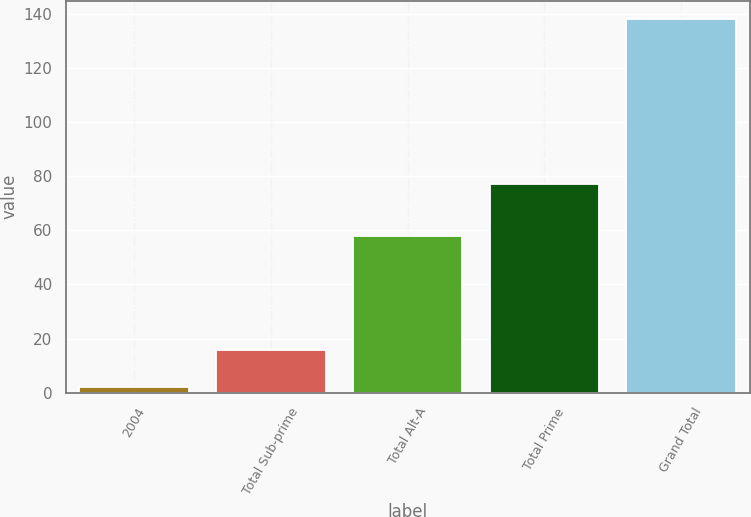Convert chart to OTSL. <chart><loc_0><loc_0><loc_500><loc_500><bar_chart><fcel>2004<fcel>Total Sub-prime<fcel>Total Alt-A<fcel>Total Prime<fcel>Grand Total<nl><fcel>2<fcel>15.6<fcel>58<fcel>77<fcel>138<nl></chart> 